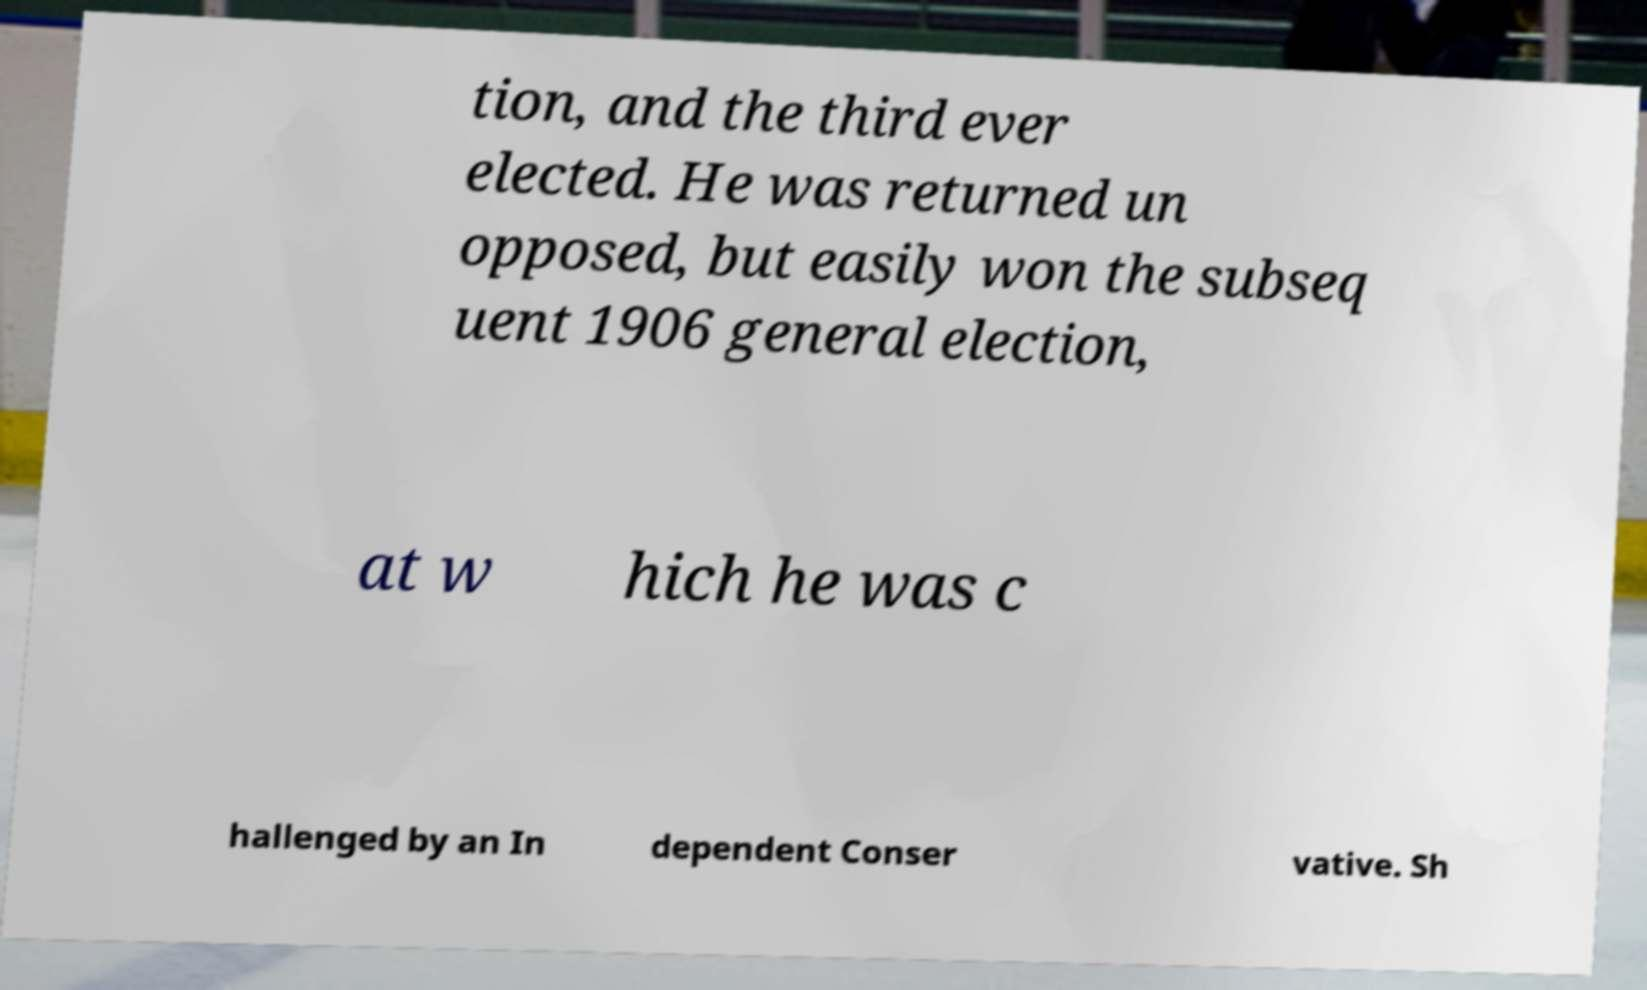Could you extract and type out the text from this image? tion, and the third ever elected. He was returned un opposed, but easily won the subseq uent 1906 general election, at w hich he was c hallenged by an In dependent Conser vative. Sh 